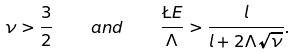Convert formula to latex. <formula><loc_0><loc_0><loc_500><loc_500>\nu > \frac { 3 } { 2 } \quad a n d \quad \frac { \L E } { \Lambda } > \frac { l } { l + 2 \Lambda \sqrt { \nu } } .</formula> 